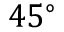<formula> <loc_0><loc_0><loc_500><loc_500>4 5 ^ { \circ }</formula> 